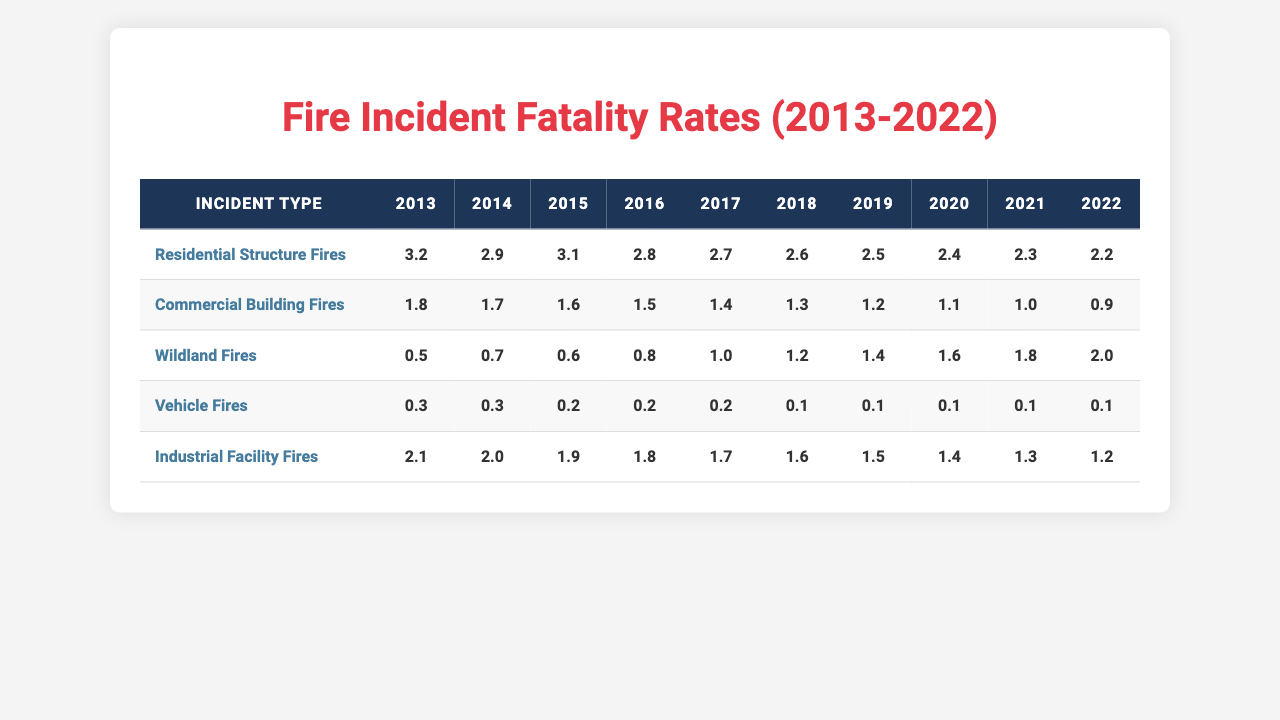What was the fatality rate for Residential Structure Fires in 2022? By referring to the table, the fatality rate for Residential Structure Fires in 2022 is found at the last column corresponding to the year 2022. The value is 2.2.
Answer: 2.2 Which type of fire incident had the highest fatality rate in 2016? Looking at the table for the year 2016, the fatality rates are compared for each incident type. The highest value is 2.8 for Residential Structure Fires.
Answer: Residential Structure Fires How did the fatality rate for Vehicle Fires change from 2013 to 2022? The fatality rate for Vehicle Fires in 2013 is 0.3 and in 2022 it is 0.1. To find the change, we subtract the 2022 value from the 2013 value: 0.3 - 0.1 = 0.2. This indicates a decrease.
Answer: Decrease of 0.2 What is the average fatality rate for Wildland Fires over the past decade? To calculate the average, we sum the fatality rates for Wildland Fires from 2013 to 2022: (0.5 + 0.7 + 0.6 + 0.8 + 1.0 + 1.2 + 1.4 + 1.6 + 1.8 + 2.0) = 11.8. Since there are 10 data points, we divide by 10: 11.8 / 10 = 1.18.
Answer: 1.18 Did the fatality rate for Industrial Facility Fires improve every year from 2013 to 2022? We check the table for Industrial Facility Fires from 2013 to 2022. The rates are: 2.1, 2.0, 1.9, 1.8, 1.7, 1.6, 1.5, 1.4, 1.3, 1.2. Each rate is consistently lower than the previous year, indicating a continuous decrease.
Answer: Yes What was the overall trend for fatality rates across all incident types from 2013 to 2022? We analyze the last values in the listed rates for each incident type in 2022. Residential Structure Fires have decreased, Commercial Building Fires have decreased, Wildland Fires have increased, Vehicle Fires have decreased, and Industrial Facility Fires have decreased. Overall, there's a mix, but the fatalities for some have risen while others have fallen, pointing out that trends can vary significantly.
Answer: Mixed trends with no consistent overall direction 